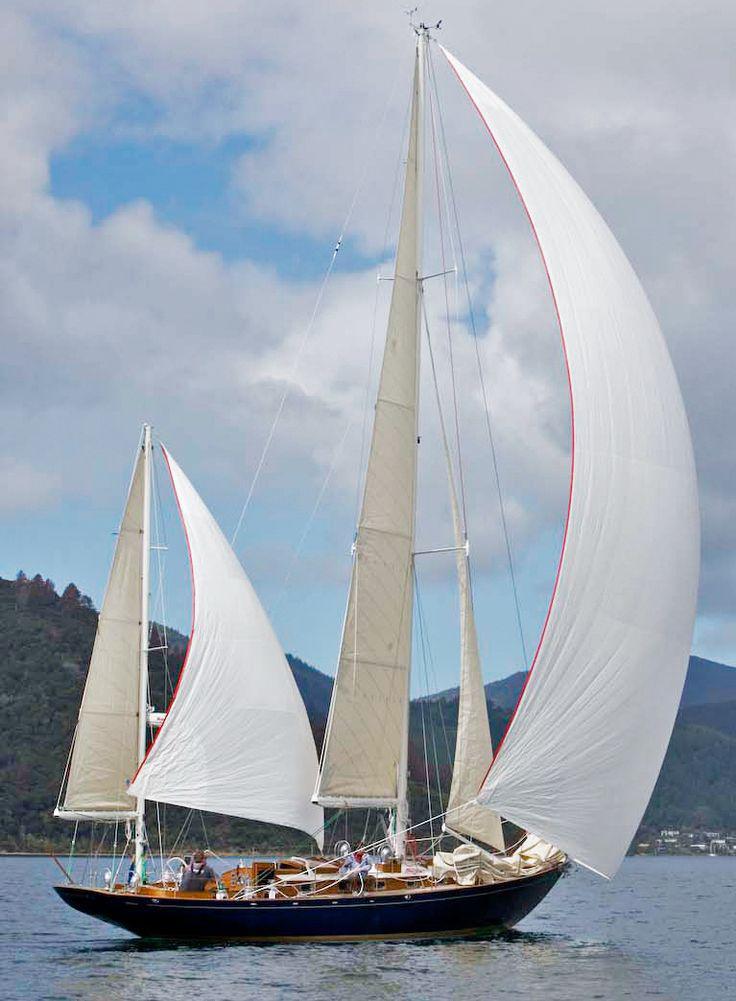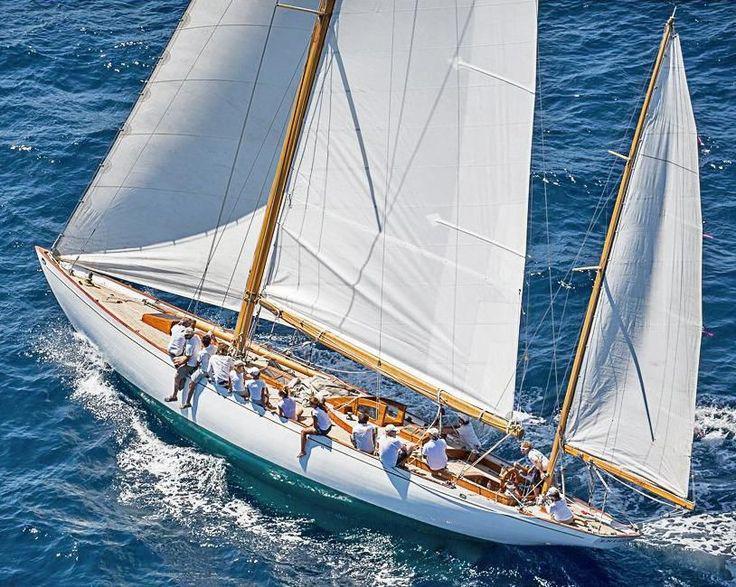The first image is the image on the left, the second image is the image on the right. Given the left and right images, does the statement "One of the images has a large group of people all wearing white shirts." hold true? Answer yes or no. Yes. 